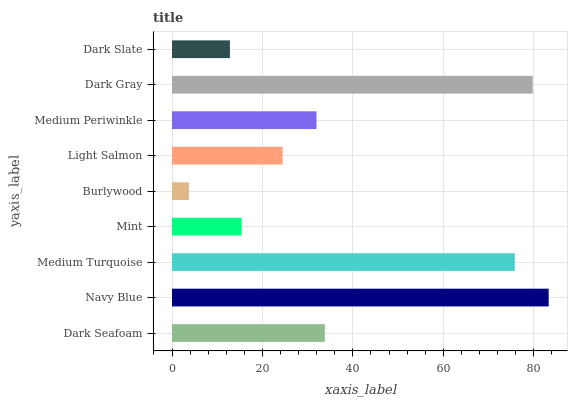Is Burlywood the minimum?
Answer yes or no. Yes. Is Navy Blue the maximum?
Answer yes or no. Yes. Is Medium Turquoise the minimum?
Answer yes or no. No. Is Medium Turquoise the maximum?
Answer yes or no. No. Is Navy Blue greater than Medium Turquoise?
Answer yes or no. Yes. Is Medium Turquoise less than Navy Blue?
Answer yes or no. Yes. Is Medium Turquoise greater than Navy Blue?
Answer yes or no. No. Is Navy Blue less than Medium Turquoise?
Answer yes or no. No. Is Medium Periwinkle the high median?
Answer yes or no. Yes. Is Medium Periwinkle the low median?
Answer yes or no. Yes. Is Dark Gray the high median?
Answer yes or no. No. Is Light Salmon the low median?
Answer yes or no. No. 